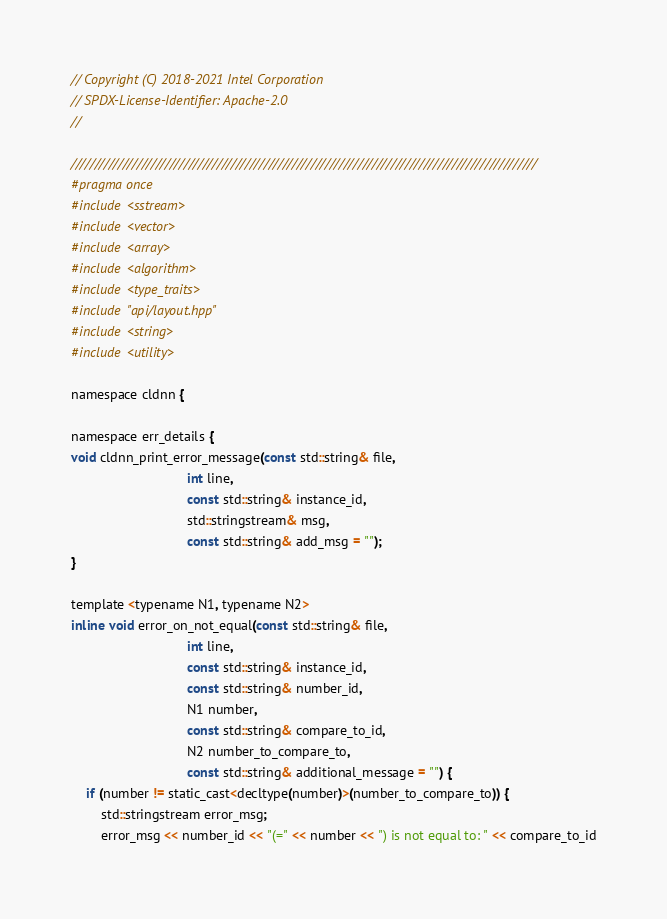Convert code to text. <code><loc_0><loc_0><loc_500><loc_500><_C_>// Copyright (C) 2018-2021 Intel Corporation
// SPDX-License-Identifier: Apache-2.0
//

///////////////////////////////////////////////////////////////////////////////////////////////////
#pragma once
#include <sstream>
#include <vector>
#include <array>
#include <algorithm>
#include <type_traits>
#include "api/layout.hpp"
#include <string>
#include <utility>

namespace cldnn {

namespace err_details {
void cldnn_print_error_message(const std::string& file,
                               int line,
                               const std::string& instance_id,
                               std::stringstream& msg,
                               const std::string& add_msg = "");
}

template <typename N1, typename N2>
inline void error_on_not_equal(const std::string& file,
                               int line,
                               const std::string& instance_id,
                               const std::string& number_id,
                               N1 number,
                               const std::string& compare_to_id,
                               N2 number_to_compare_to,
                               const std::string& additional_message = "") {
    if (number != static_cast<decltype(number)>(number_to_compare_to)) {
        std::stringstream error_msg;
        error_msg << number_id << "(=" << number << ") is not equal to: " << compare_to_id</code> 